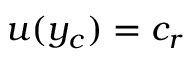Convert formula to latex. <formula><loc_0><loc_0><loc_500><loc_500>u ( y _ { c } ) = c _ { r }</formula> 